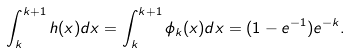Convert formula to latex. <formula><loc_0><loc_0><loc_500><loc_500>\int _ { k } ^ { k + 1 } h ( x ) d x = \int _ { k } ^ { k + 1 } \phi _ { k } ( x ) d x = ( 1 - e ^ { - 1 } ) e ^ { - k } .</formula> 